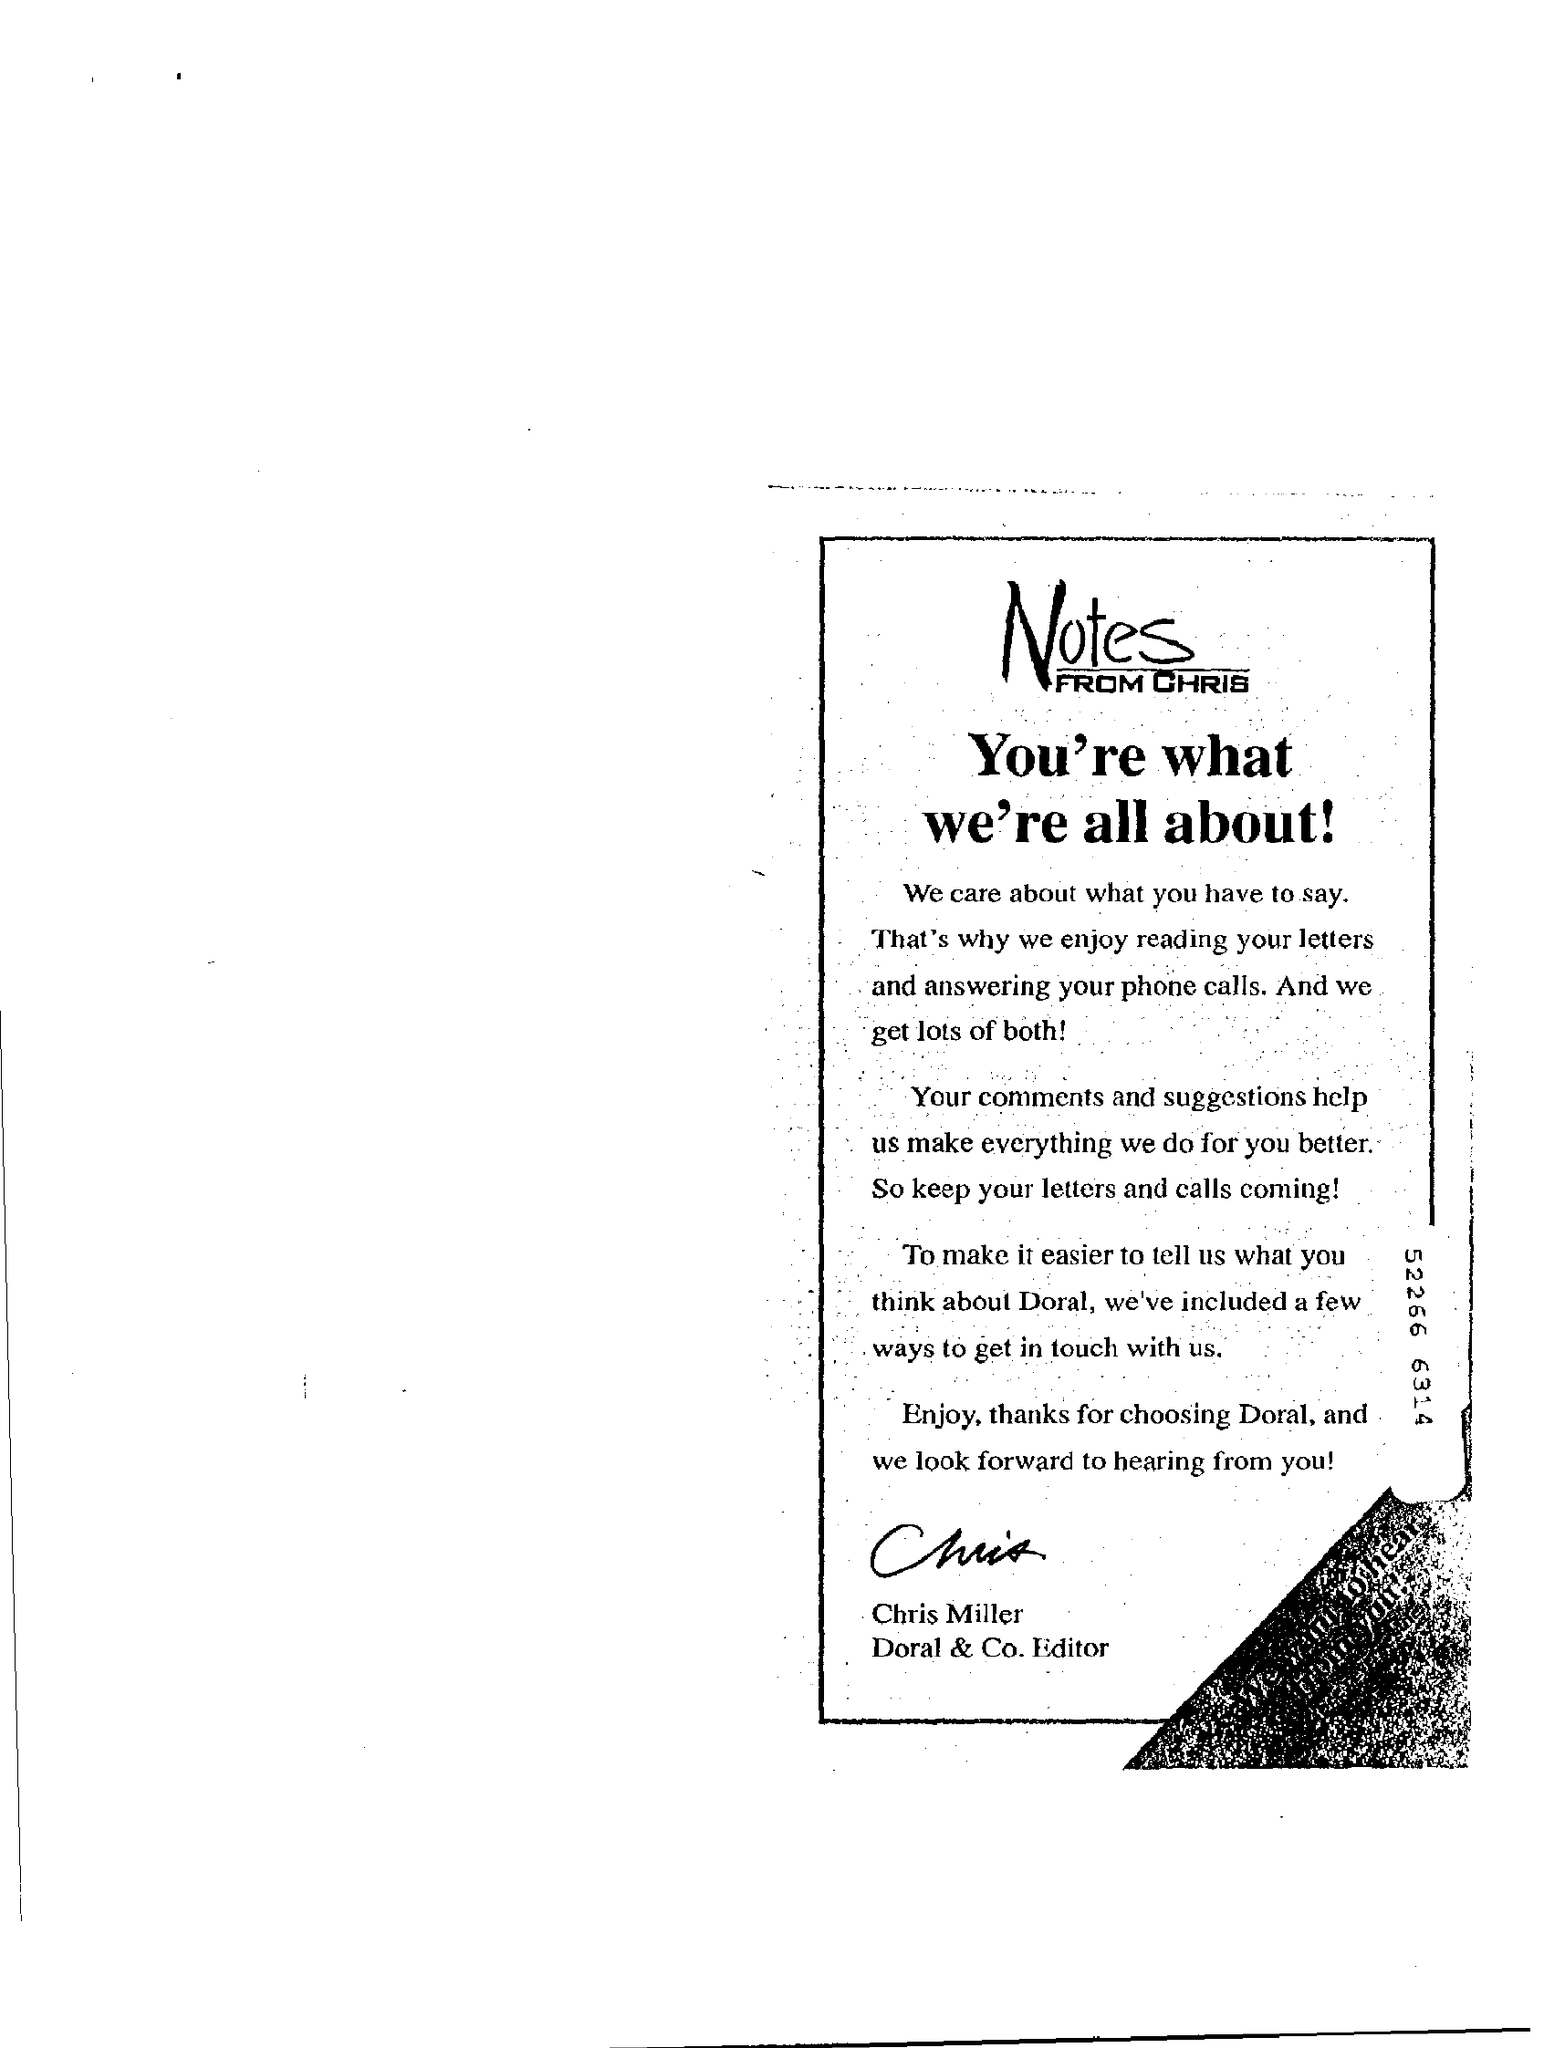Who has written the "Notes"?
Offer a very short reply. Chris miller. What title is given to "Notes FROM CHRIS"?
Offer a terse response. You're what we're all about!. "Thanks for choosing" whom is mentioned in the "Notes"?
Offer a terse response. Doral. What number is given on the right side of the page?
Keep it short and to the point. 52266 6314. 